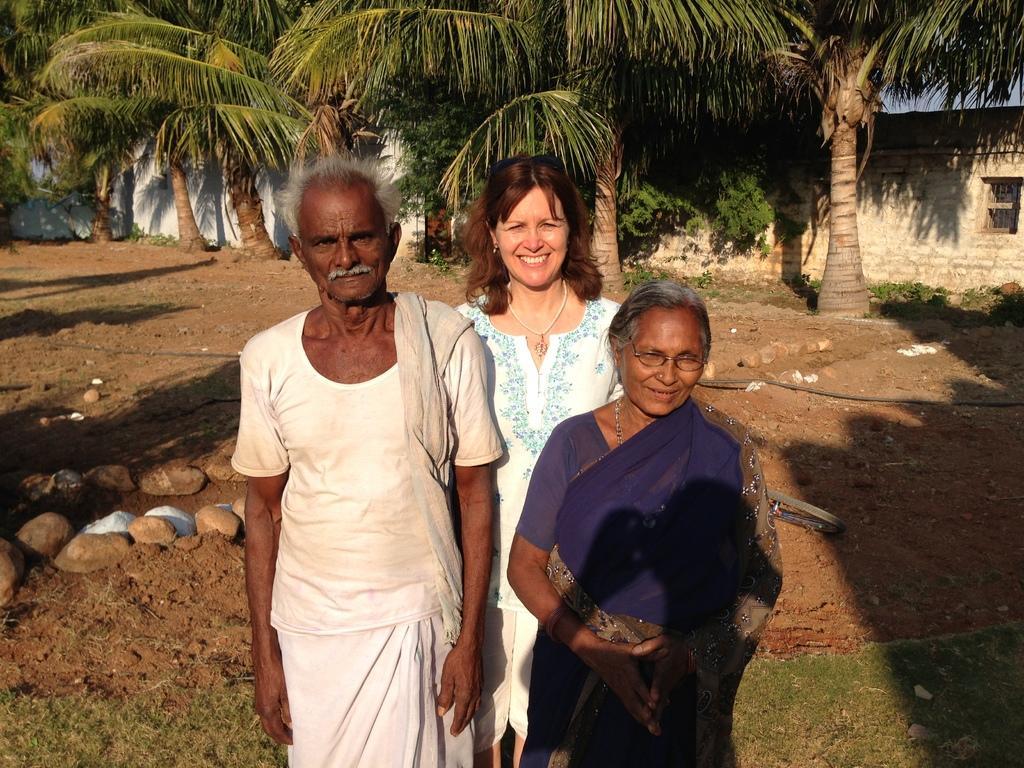In one or two sentences, can you explain what this image depicts? In this picture I can see three persons standing, there are rocks, plants, grass, there are trees, and in the background there are walls. 